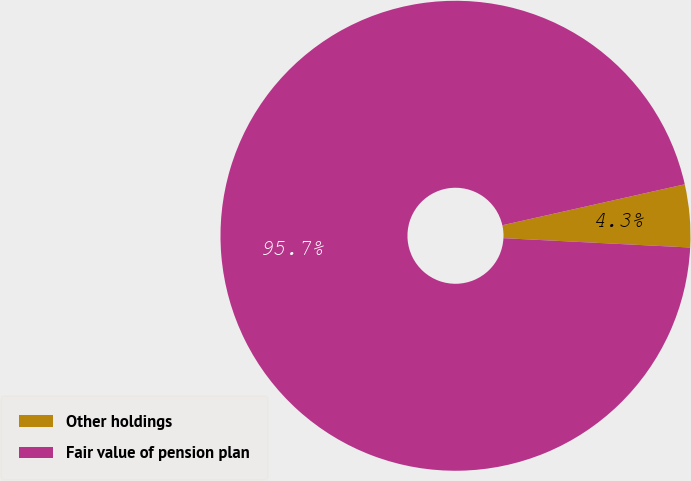Convert chart to OTSL. <chart><loc_0><loc_0><loc_500><loc_500><pie_chart><fcel>Other holdings<fcel>Fair value of pension plan<nl><fcel>4.31%<fcel>95.69%<nl></chart> 